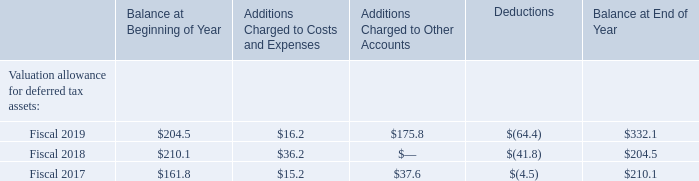Note 22. Supplemental Financial Information
Cash paid for income taxes amounted to $77.6 million, $25.9 million and $48.4 million during fiscal 2019, 2018 and 2017, respectively. Cash paid for interest on borrowings amounted to $347.9 million, $85.3 million and $82.5 million during fiscal 2019, 2018 and 2017, respectively.
A summary of additions and deductions related to the valuation allowance for deferred tax asset accounts for the years ended March 31, 2019, 2018 and 2017 follows (amounts in millions):
Which years does the table provide information for the additions and deductions related to the valuation allowance for deferred tax asset accounts? 2019, 2018, 2017. What was the balance at beginning of year in 2018?
Answer scale should be: million. 210.1. What were the deductions in 2017?
Answer scale should be: million. (4.5). How many years did the balance at beginning of year exceed $200 million? 2019##2018
Answer: 2. What was the change in the Additions Charged to Costs and Expenses between 2017 and 2019?
Answer scale should be: million. 175.8-37.6
Answer: 138.2. What was the percentage change in the Balance at End of Year between 2018 and 2019?
Answer scale should be: percent. (332.1-204.5)/204.5
Answer: 62.4. 